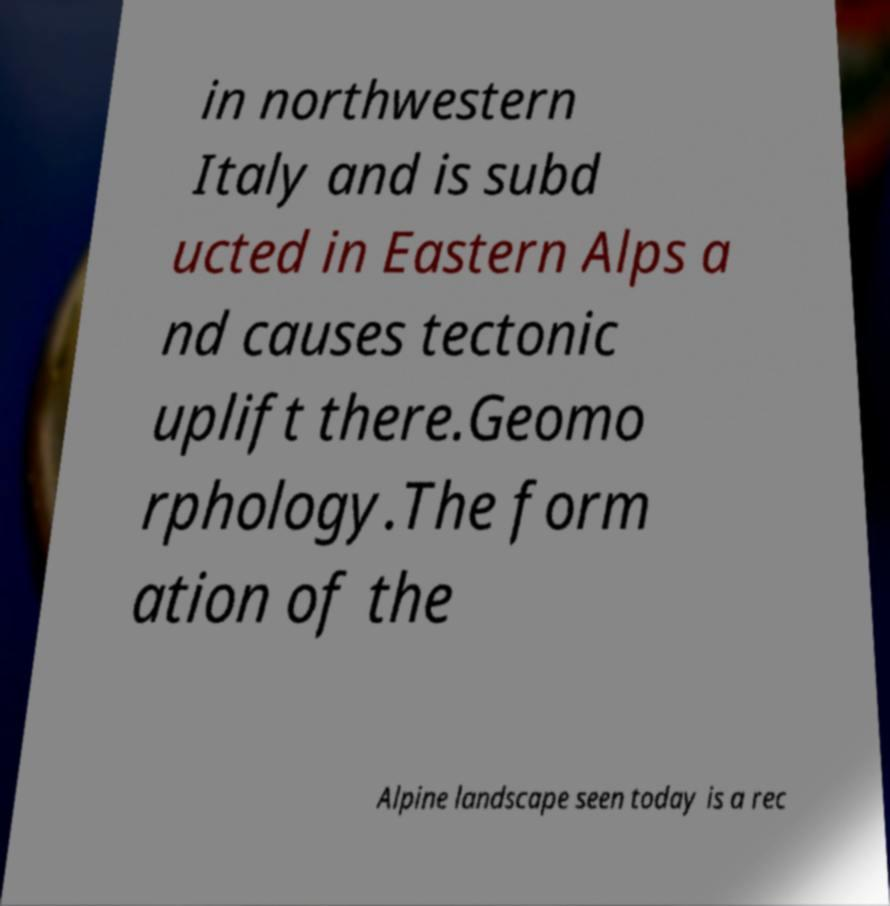Please read and relay the text visible in this image. What does it say? in northwestern Italy and is subd ucted in Eastern Alps a nd causes tectonic uplift there.Geomo rphology.The form ation of the Alpine landscape seen today is a rec 